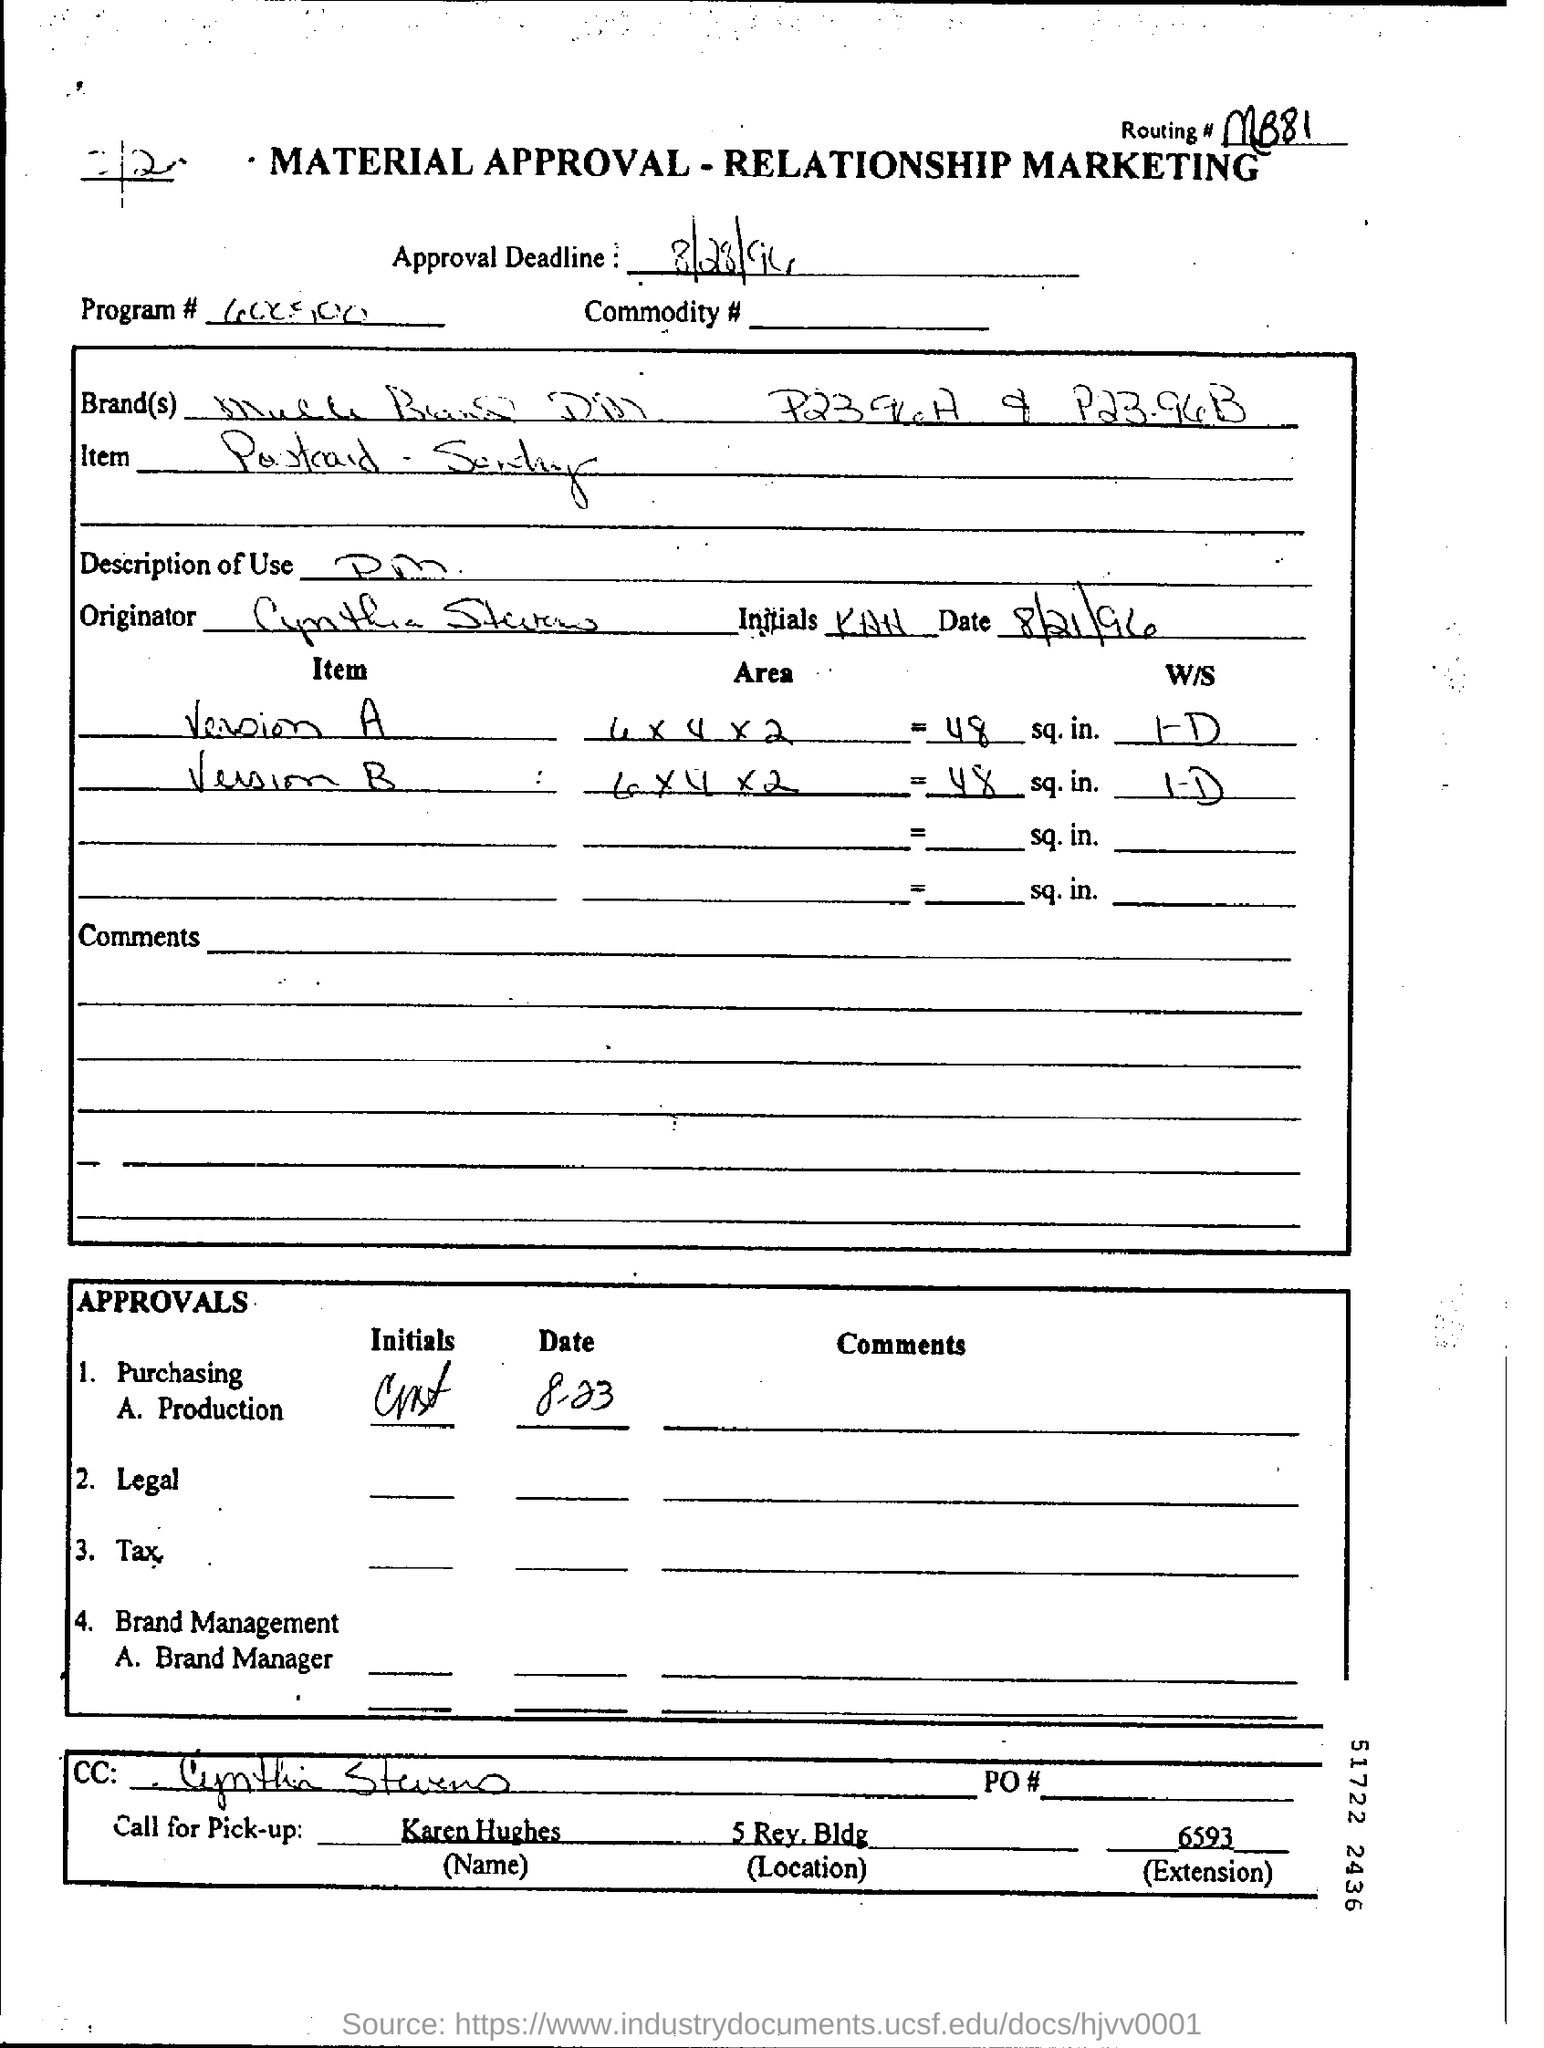Indicate a few pertinent items in this graphic. The given routing number is mB81.. The approval deadline is August 28, 1994. The approval deadline mentioned in the form is August 28, 1994. Karen Hughes should be contacted for pick-up. Cynthia Stevens is the person who is marked in the cc. 